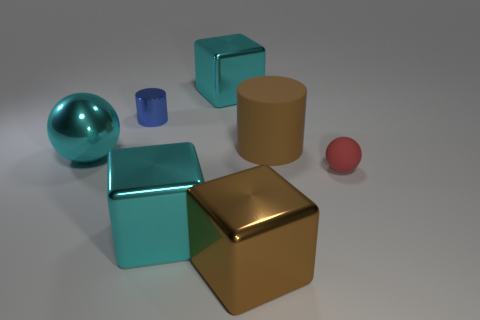Add 1 big purple spheres. How many objects exist? 8 Subtract all cyan shiny cubes. How many cubes are left? 1 Subtract all cylinders. How many objects are left? 5 Subtract 1 cylinders. How many cylinders are left? 1 Subtract all cyan balls. How many cyan blocks are left? 2 Add 6 brown shiny cylinders. How many brown shiny cylinders exist? 6 Subtract all red spheres. How many spheres are left? 1 Subtract 0 green blocks. How many objects are left? 7 Subtract all purple cylinders. Subtract all red balls. How many cylinders are left? 2 Subtract all large brown rubber cylinders. Subtract all small blue cylinders. How many objects are left? 5 